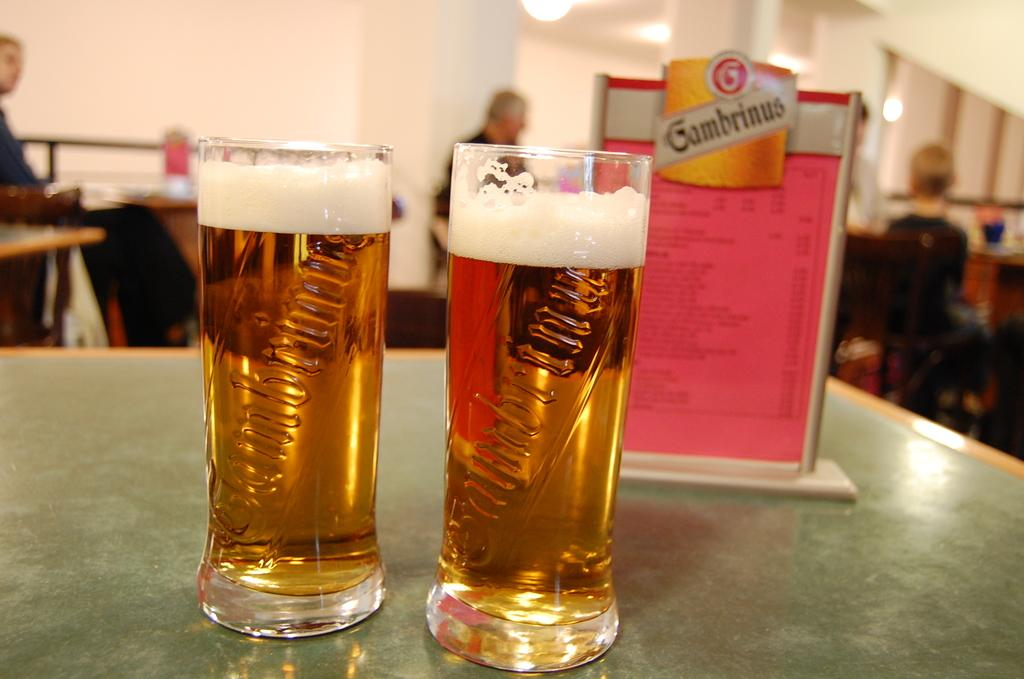Provide a one-sentence caption for the provided image. Two nearly full pints of Gabmrinus beer sit on a table. 